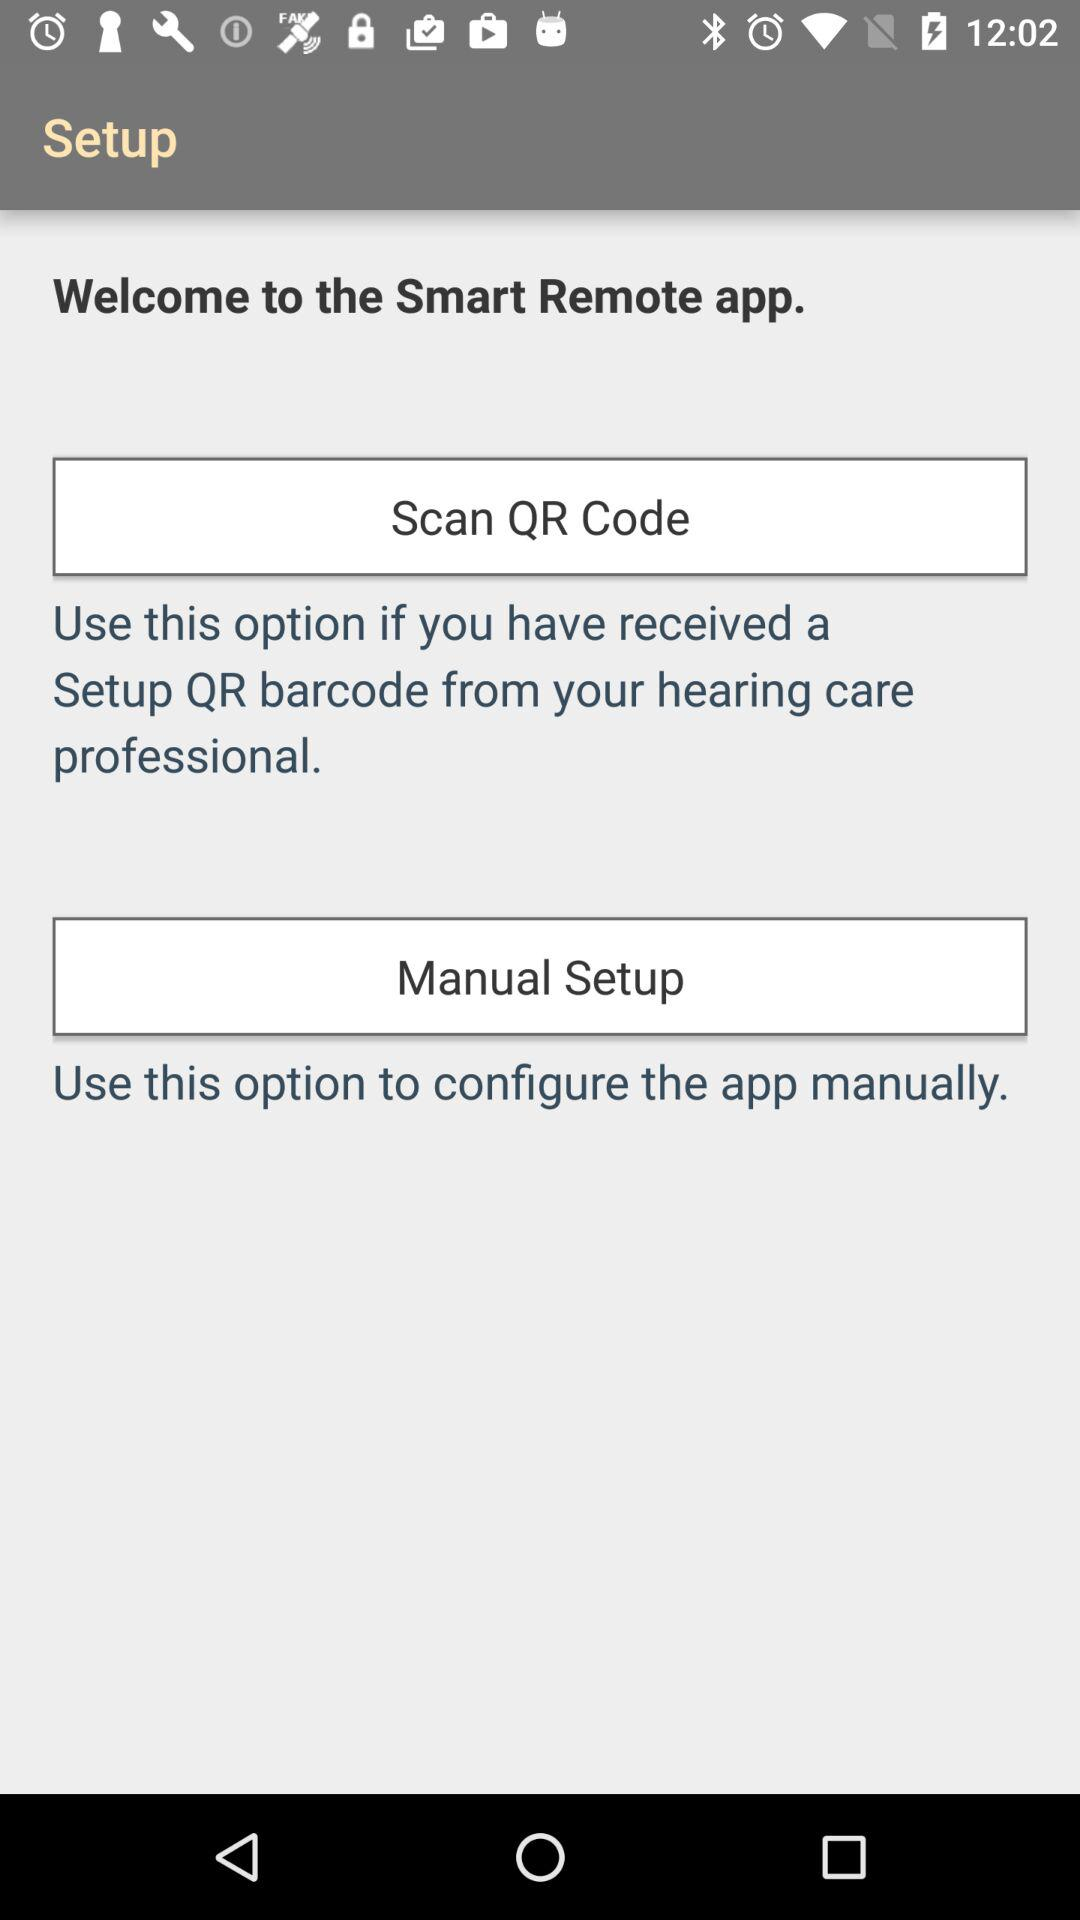How many options are there to setup the app?
Answer the question using a single word or phrase. 2 